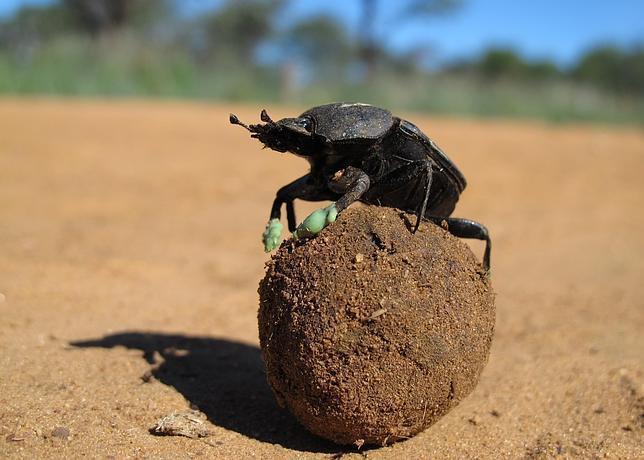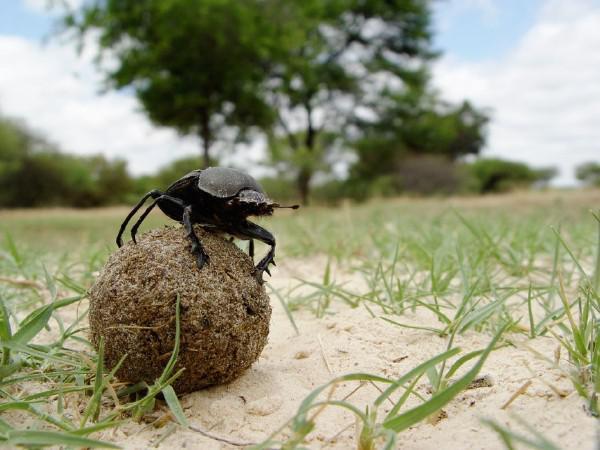The first image is the image on the left, the second image is the image on the right. Given the left and right images, does the statement "Each image shows exactly one beetle." hold true? Answer yes or no. Yes. The first image is the image on the left, the second image is the image on the right. Assess this claim about the two images: "An image in the pair shows exactly two beetles with a dung ball.". Correct or not? Answer yes or no. No. 